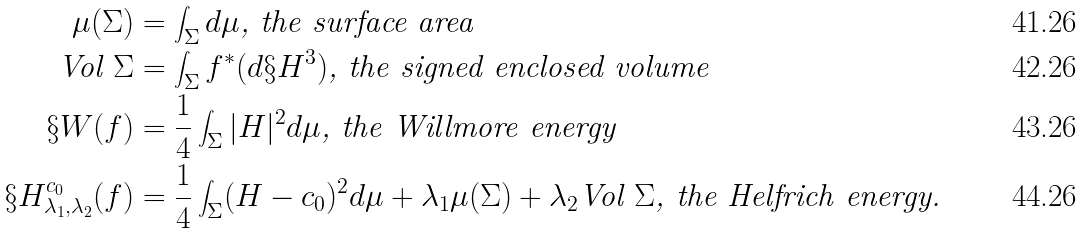<formula> <loc_0><loc_0><loc_500><loc_500>\mu ( \Sigma ) & = \int _ { \Sigma } d \mu \text {, the surface area} \\ \text {Vol $\Sigma$} & = \int _ { \Sigma } f ^ { * } ( d \S H ^ { 3 } ) \text {, the signed enclosed volume} \\ \S W ( f ) & = \frac { 1 } { 4 } \int _ { \Sigma } | H | ^ { 2 } d \mu \text {, the Willmore energy} \\ \S H ^ { c _ { 0 } } _ { \lambda _ { 1 } , \lambda _ { 2 } } ( f ) & = \frac { 1 } { 4 } \int _ { \Sigma } ( H - c _ { 0 } ) ^ { 2 } d \mu + \lambda _ { 1 } \mu ( \Sigma ) + \lambda _ { 2 } \text {Vol $\Sigma$} \text {, the Helfrich energy.}</formula> 